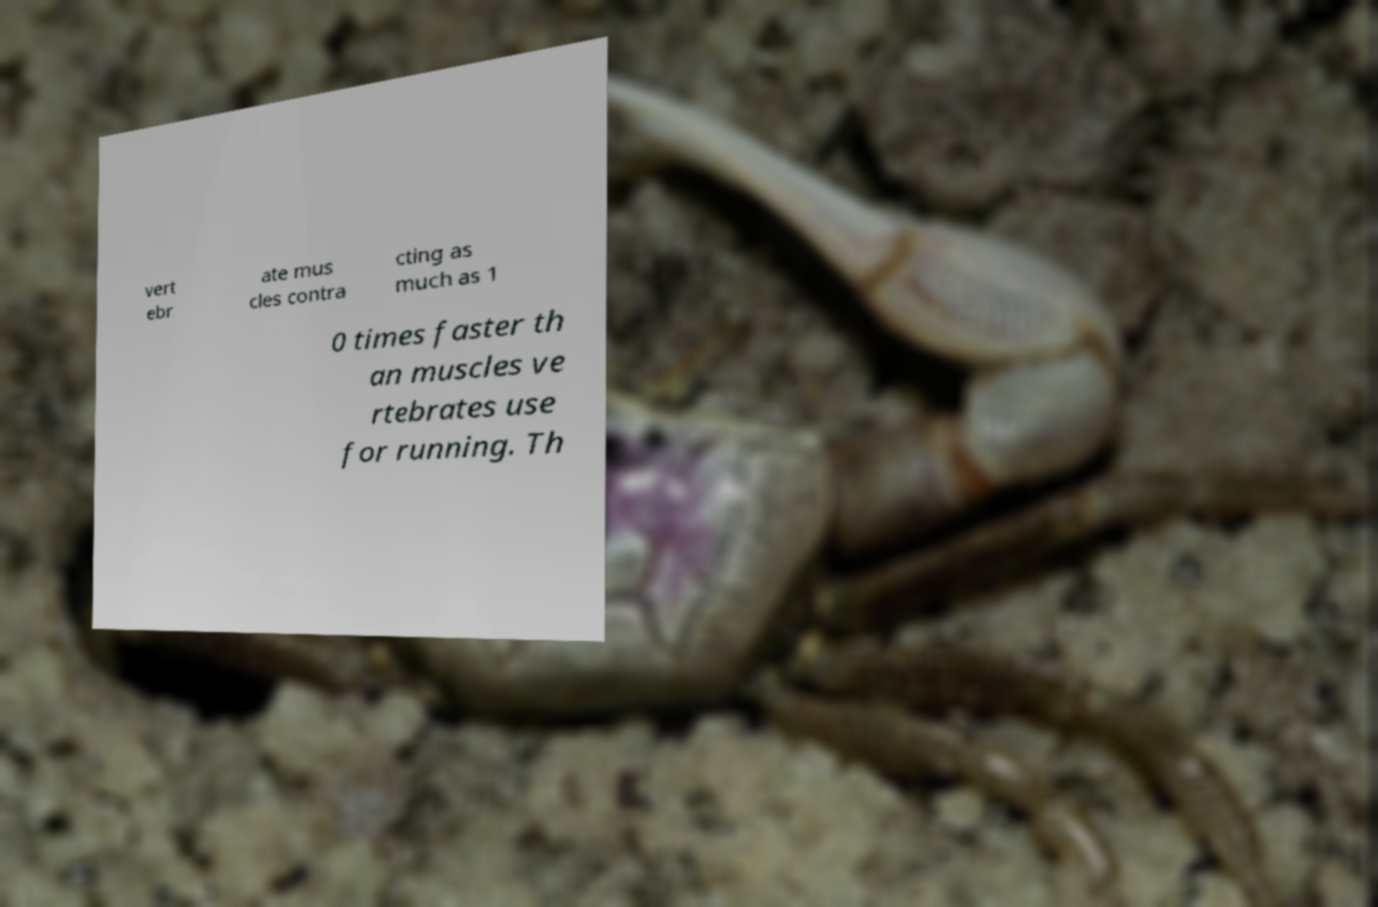Can you accurately transcribe the text from the provided image for me? vert ebr ate mus cles contra cting as much as 1 0 times faster th an muscles ve rtebrates use for running. Th 